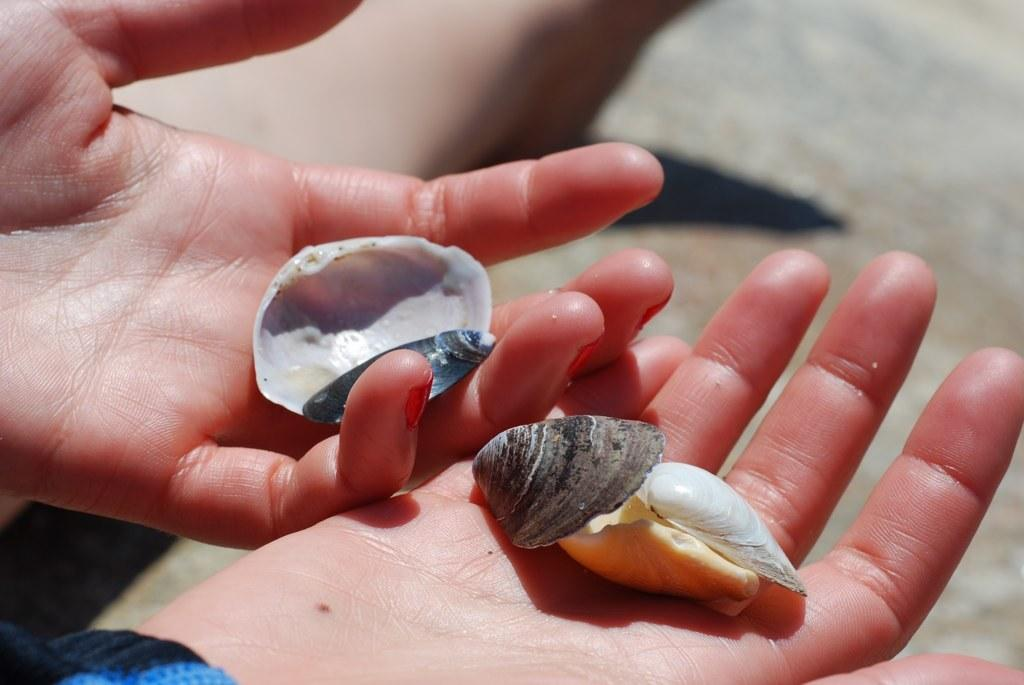Who is present in the image? There is a person in the image. What is the person holding in the image? The person is holding seashells. Can you describe the background of the image? The background of the image is blurred. What type of plot can be seen in the background of the image? There is no plot visible in the image; the background is blurred. 